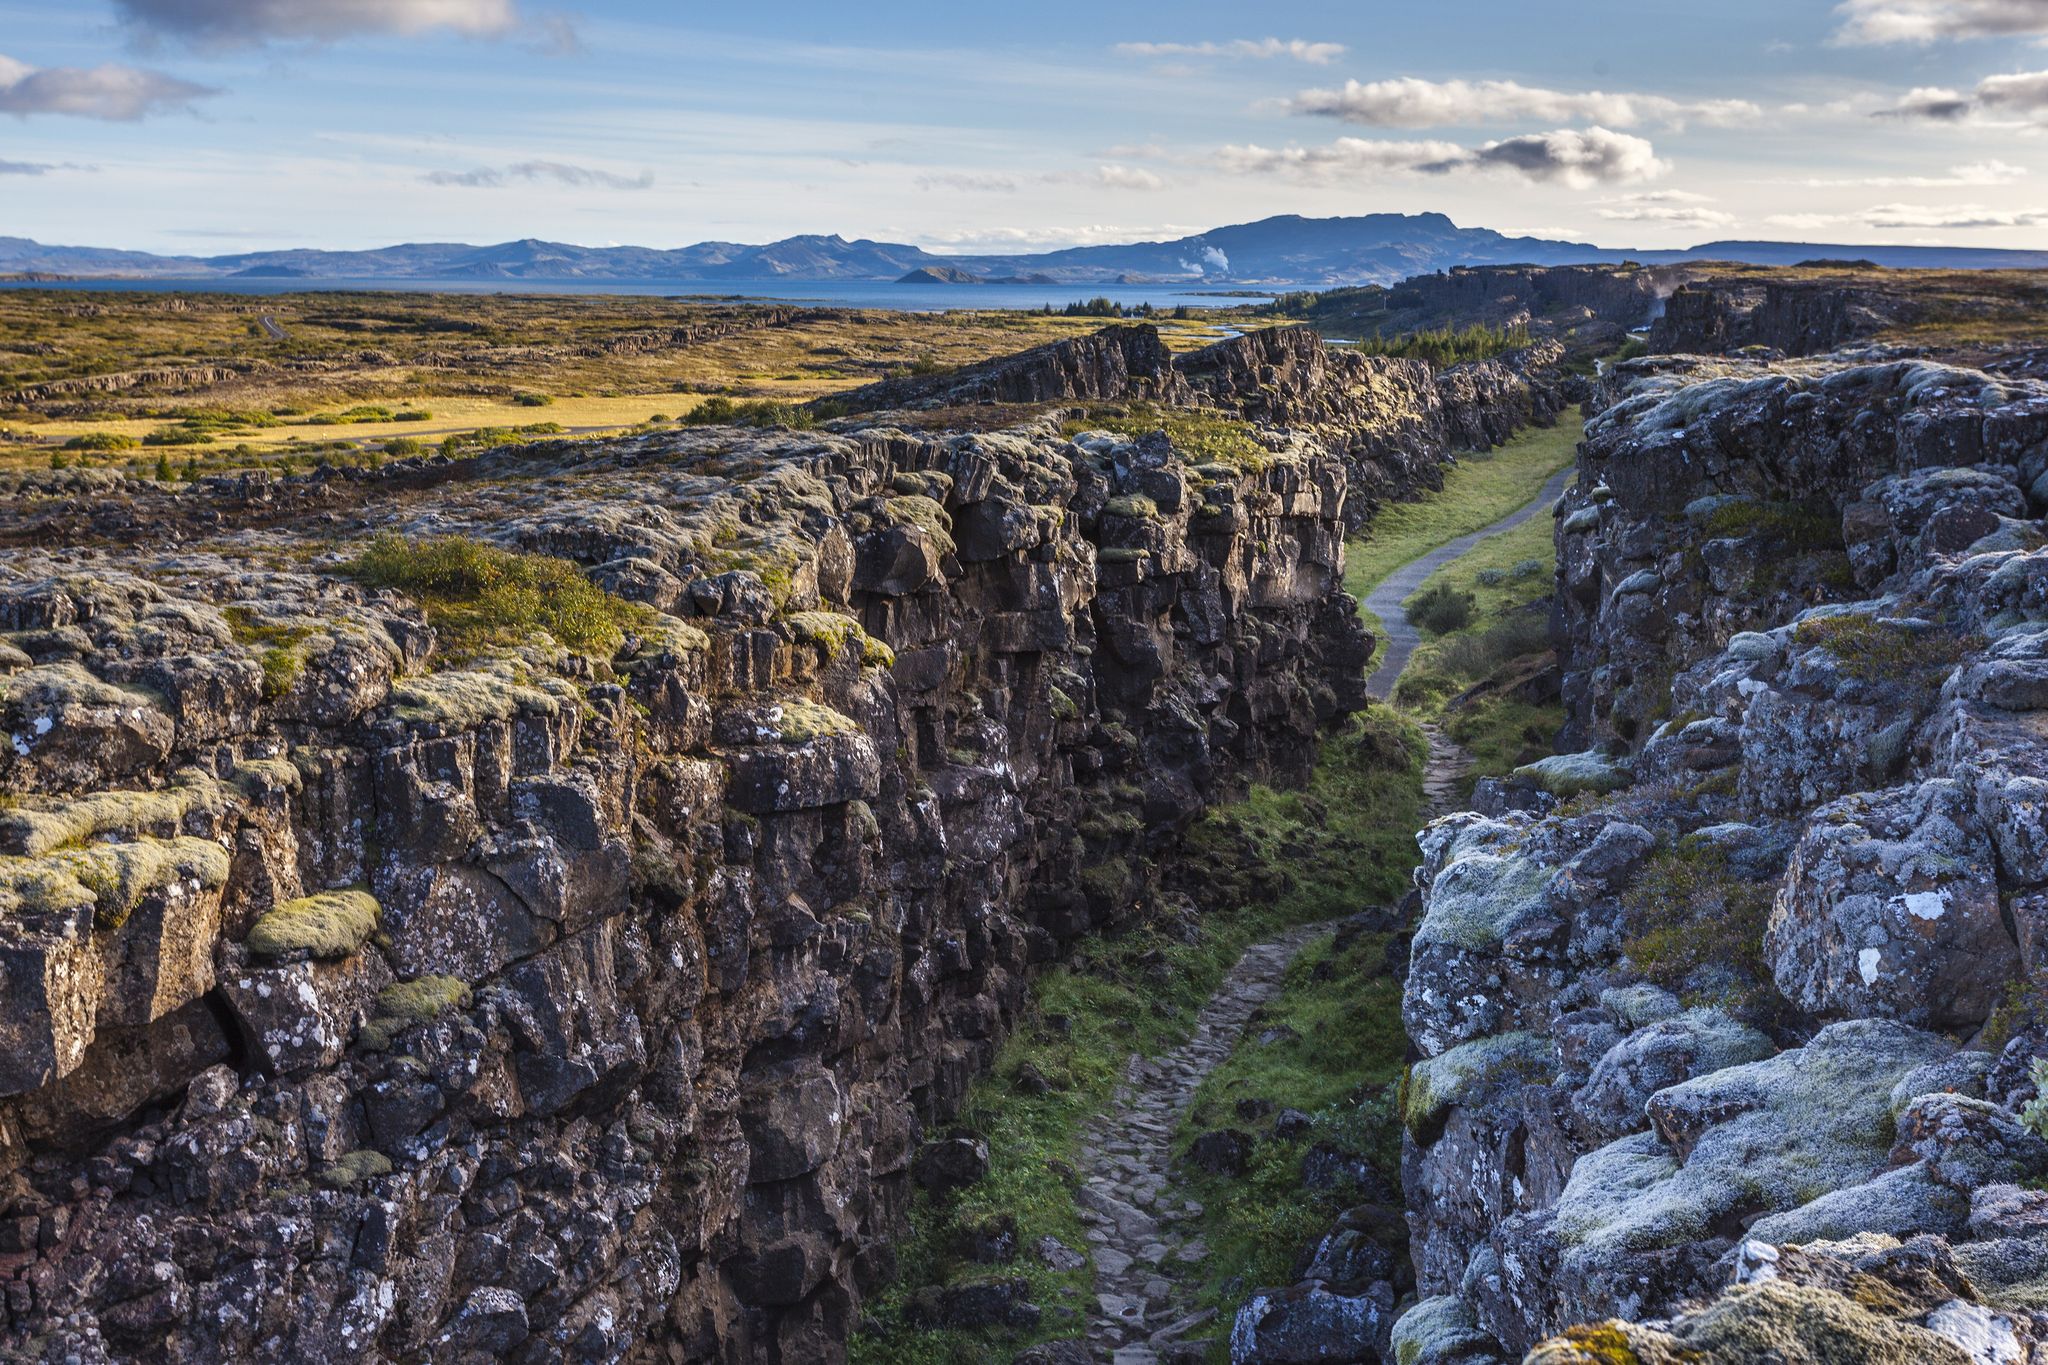What kind of flora and fauna might one encounter in this area? Þingvellir National Park is home to a diverse range of flora and fauna. The vegetation includes a variety of mosses, lichens, grasses, and wildflowers that flourish in the unique climate and geological conditions. Among the fauna, visitors might encounter Arctic foxes, which are native to the region, and various bird species such as the rock ptarmigan, redwing, and golden plover. The park's waters are inhabited by different fish species, including brown trout and Arctic char, making it a popular destination for fishing enthusiasts. Could you describe an early morning hike in the park? An early morning hike at Þingvellir National Park is an invigorating experience. As dawn breaks, the first light of the day casts a soft, ethereal glow over the landscape. The air is crisp and fresh, filled with the gentle sounds of nature waking up. The path through the gorge is lined with dew-covered moss and grasses, sparkling like tiny jewels in the morning light. The solitude of the early hour allows for a deep connection with the surroundings, as the colors and textures of the rocks and vegetation slowly come to life. Birds begin their morning chorus, and occasionally, the distant rumble of geothermal activity can be heard. The hike offers moments of stillness and reflection, as well as the awe-inspiring beauty of Iceland's natural wonders unfolding with every step. It's a time when the park feels almost magical, a perfect blend of serenity and the raw power of the earth. 